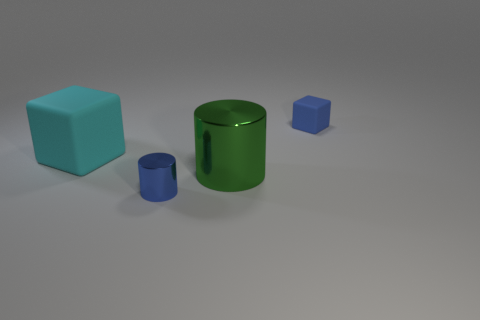What number of objects are either large green objects that are to the right of the tiny shiny thing or tiny yellow metallic cubes?
Ensure brevity in your answer.  1. The small cube is what color?
Keep it short and to the point. Blue. What is the small blue object that is behind the cyan thing made of?
Offer a terse response. Rubber. There is a small shiny object; is its shape the same as the big metal thing on the right side of the tiny shiny thing?
Offer a terse response. Yes. Are there more big yellow things than tiny blue cylinders?
Provide a succinct answer. No. Is there any other thing that has the same color as the tiny matte thing?
Keep it short and to the point. Yes. What shape is the big cyan object that is the same material as the tiny blue block?
Your response must be concise. Cube. What is the material of the small blue object that is in front of the rubber object behind the big matte object?
Your response must be concise. Metal. Do the blue object in front of the big green object and the green metallic thing have the same shape?
Give a very brief answer. Yes. Is the number of large green things that are on the right side of the cyan rubber thing greater than the number of brown rubber cubes?
Give a very brief answer. Yes. 